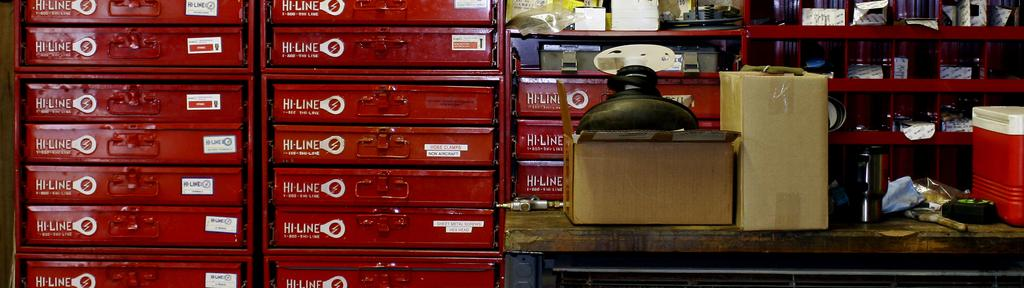<image>
Provide a brief description of the given image. A red Hi-Line tool box sits next to a desk. 